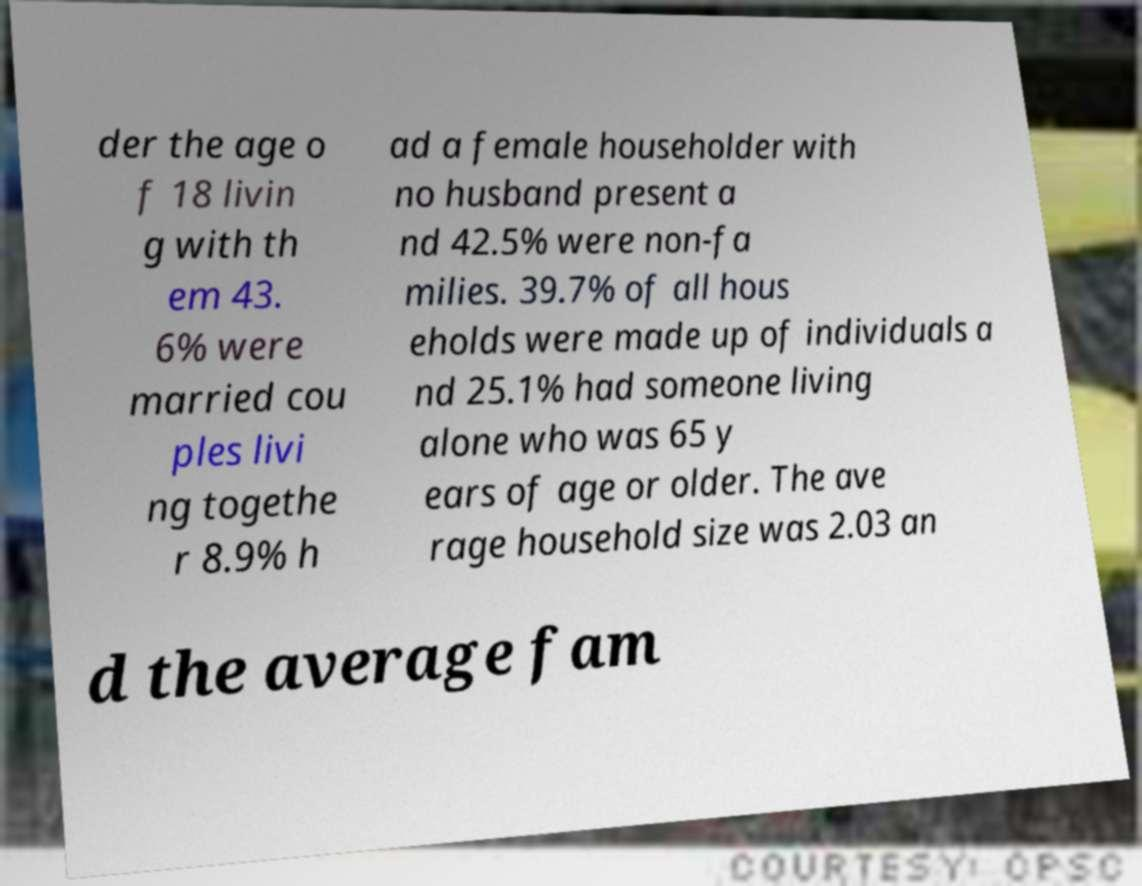Could you extract and type out the text from this image? der the age o f 18 livin g with th em 43. 6% were married cou ples livi ng togethe r 8.9% h ad a female householder with no husband present a nd 42.5% were non-fa milies. 39.7% of all hous eholds were made up of individuals a nd 25.1% had someone living alone who was 65 y ears of age or older. The ave rage household size was 2.03 an d the average fam 